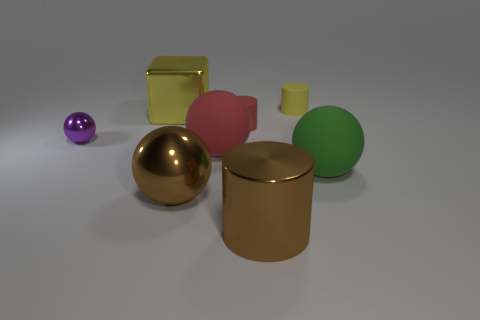The metal cylinder that is to the right of the large red object is what color?
Provide a short and direct response. Brown. There is a yellow thing that is the same size as the green object; what shape is it?
Offer a very short reply. Cube. There is a shiny cylinder; is its color the same as the metal sphere that is on the right side of the yellow shiny thing?
Keep it short and to the point. Yes. How many objects are either matte cylinders in front of the yellow shiny object or small cylinders to the left of the large shiny cylinder?
Provide a short and direct response. 1. There is a yellow block that is the same size as the green thing; what is its material?
Provide a succinct answer. Metal. How many other things are there of the same material as the small yellow object?
Your response must be concise. 3. There is a red matte thing that is in front of the tiny red rubber thing; is its shape the same as the brown metallic thing behind the big cylinder?
Ensure brevity in your answer.  Yes. What color is the tiny rubber cylinder that is behind the yellow thing to the left of the big brown metallic object that is on the right side of the large brown shiny sphere?
Ensure brevity in your answer.  Yellow. What number of other things are the same color as the small metallic ball?
Your answer should be very brief. 0. Are there fewer yellow cubes than brown shiny things?
Make the answer very short. Yes. 